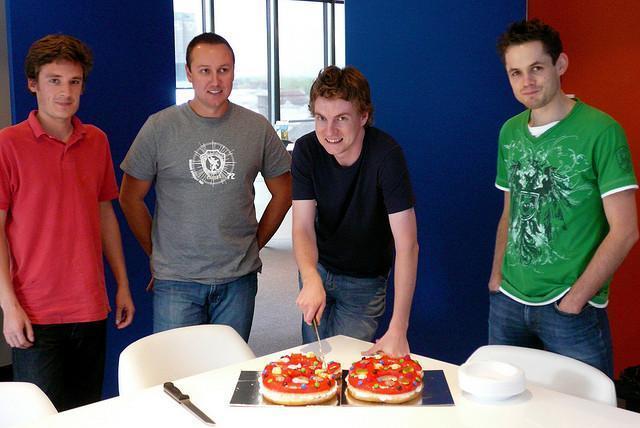How many men are wearing white?
Give a very brief answer. 0. How many people are there?
Give a very brief answer. 4. How many chairs are in the picture?
Give a very brief answer. 2. How many cakes can be seen?
Give a very brief answer. 2. 